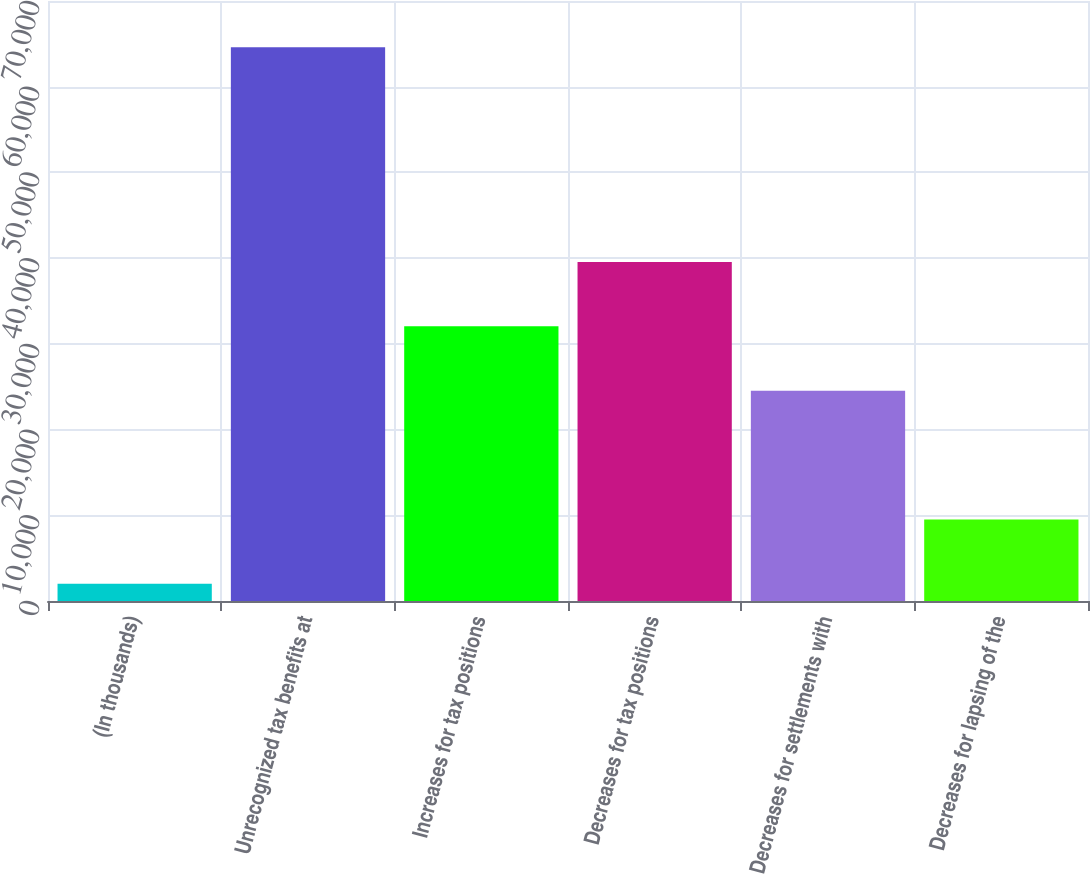Convert chart to OTSL. <chart><loc_0><loc_0><loc_500><loc_500><bar_chart><fcel>(In thousands)<fcel>Unrecognized tax benefits at<fcel>Increases for tax positions<fcel>Decreases for tax positions<fcel>Decreases for settlements with<fcel>Decreases for lapsing of the<nl><fcel>2008<fcel>64602<fcel>32052.4<fcel>39563.5<fcel>24541.3<fcel>9519.1<nl></chart> 